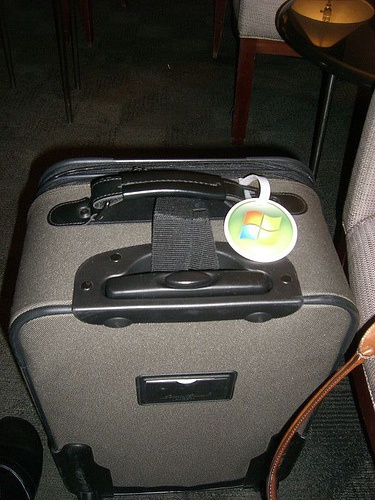Describe the objects in this image and their specific colors. I can see suitcase in black, gray, and darkgray tones, handbag in black, gray, and maroon tones, chair in black, gray, and maroon tones, and couch in black, darkgray, and gray tones in this image. 